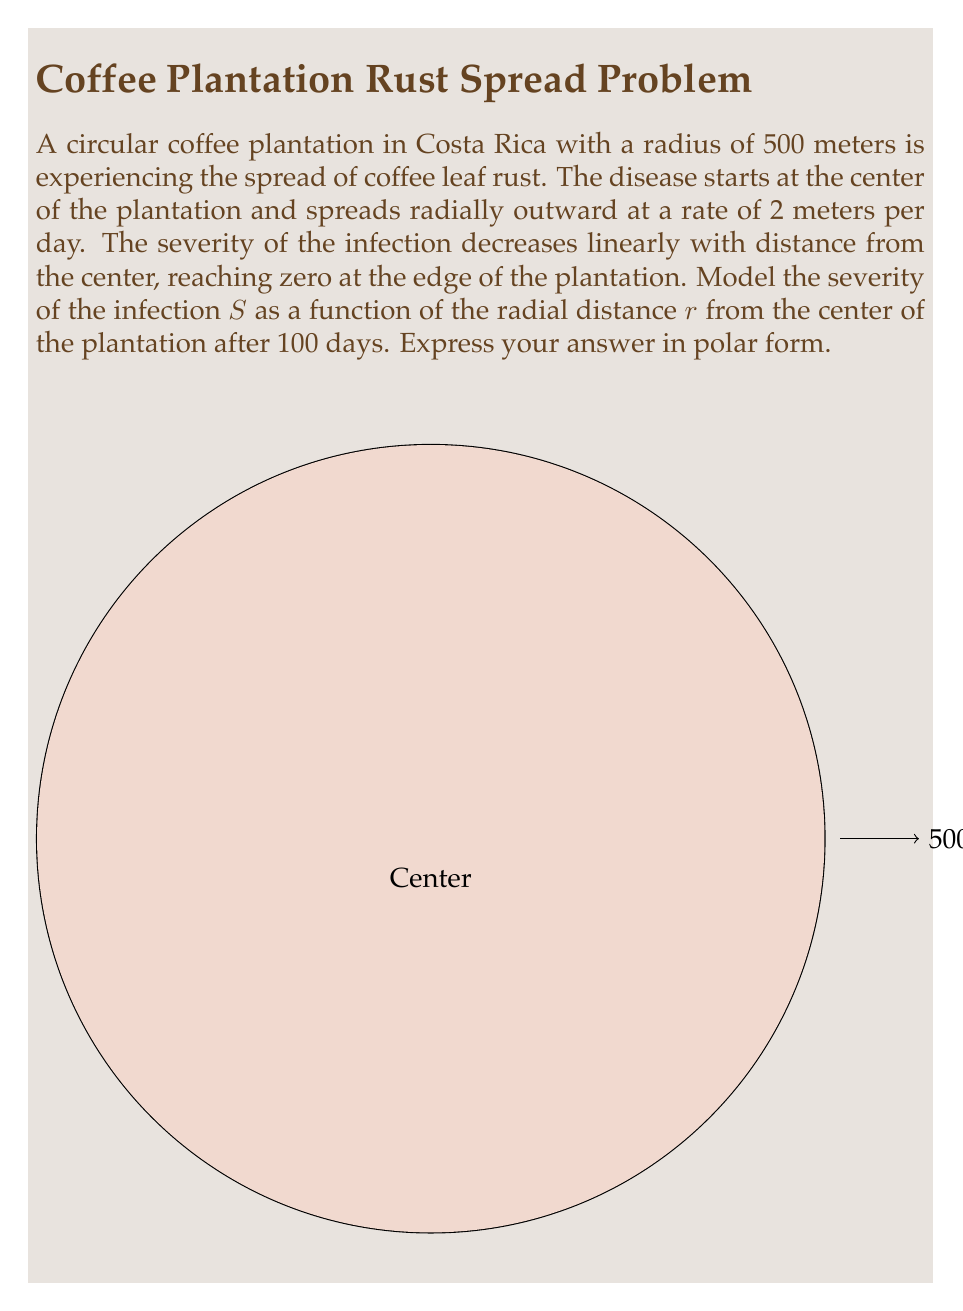Could you help me with this problem? Let's approach this step-by-step:

1) First, we need to determine how far the disease has spread after 100 days:
   Distance spread = Rate × Time
   $$ d = 2 \text{ m/day} \times 100 \text{ days} = 200 \text{ m} $$

2) The severity of the infection is highest at the center and decreases linearly to zero at the edge of the infected area. We can model this with a linear function:
   $$ S(r) = a - br $$
   where $a$ is the maximum severity at the center and $b$ is the rate of decrease.

3) We know two points on this line:
   - At $r = 0$, $S = a$ (maximum severity)
   - At $r = 200$, $S = 0$ (edge of infected area)

4) Using the second point, we can write:
   $$ 0 = a - 200b $$
   $$ a = 200b $$

5) Substituting this back into our original equation:
   $$ S(r) = 200b - br = b(200 - r) $$

6) To find $b$, we can use the fact that $S(0) = a = 200b = 1$ (assuming maximum severity is 1):
   $$ 200b = 1 $$
   $$ b = \frac{1}{200} $$

7) Our final equation in Cartesian form is:
   $$ S(r) = \frac{200 - r}{200} \text{ for } 0 \leq r \leq 200 $$

8) To convert to polar form, we simply replace $r$ with $\rho$:
   $$ S(\rho) = \frac{200 - \rho}{200} \text{ for } 0 \leq \rho \leq 200 $$

This equation is valid for the infected area. Beyond 200 meters, the severity is zero.
Answer: $$S(\rho) = \begin{cases} 
\frac{200 - \rho}{200} & \text{for } 0 \leq \rho \leq 200 \\
0 & \text{for } 200 < \rho \leq 500
\end{cases}$$ 